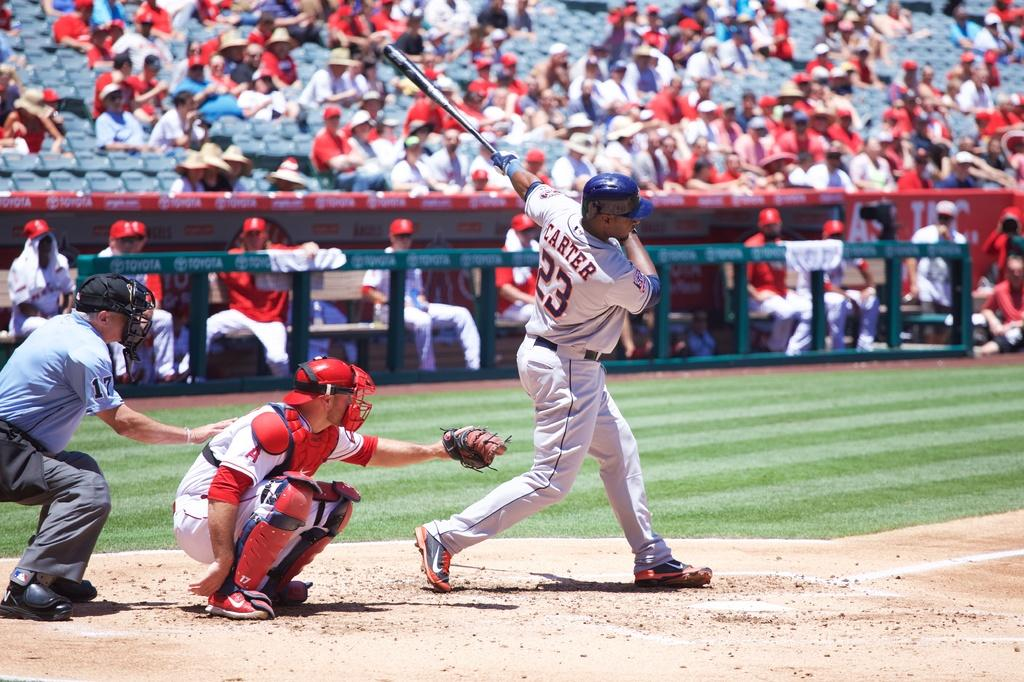<image>
Write a terse but informative summary of the picture. Baseball player by the name of the Carter # 23 is swinging his bat to hit the ball. 